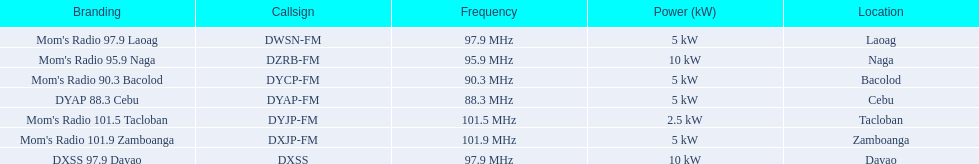What brandings have a power of 5 kw? Mom's Radio 97.9 Laoag, Mom's Radio 90.3 Bacolod, DYAP 88.3 Cebu, Mom's Radio 101.9 Zamboanga. Which of these has a call-sign beginning with dy? Mom's Radio 90.3 Bacolod, DYAP 88.3 Cebu. Which of those uses the lowest frequency? DYAP 88.3 Cebu. 